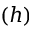<formula> <loc_0><loc_0><loc_500><loc_500>( h )</formula> 